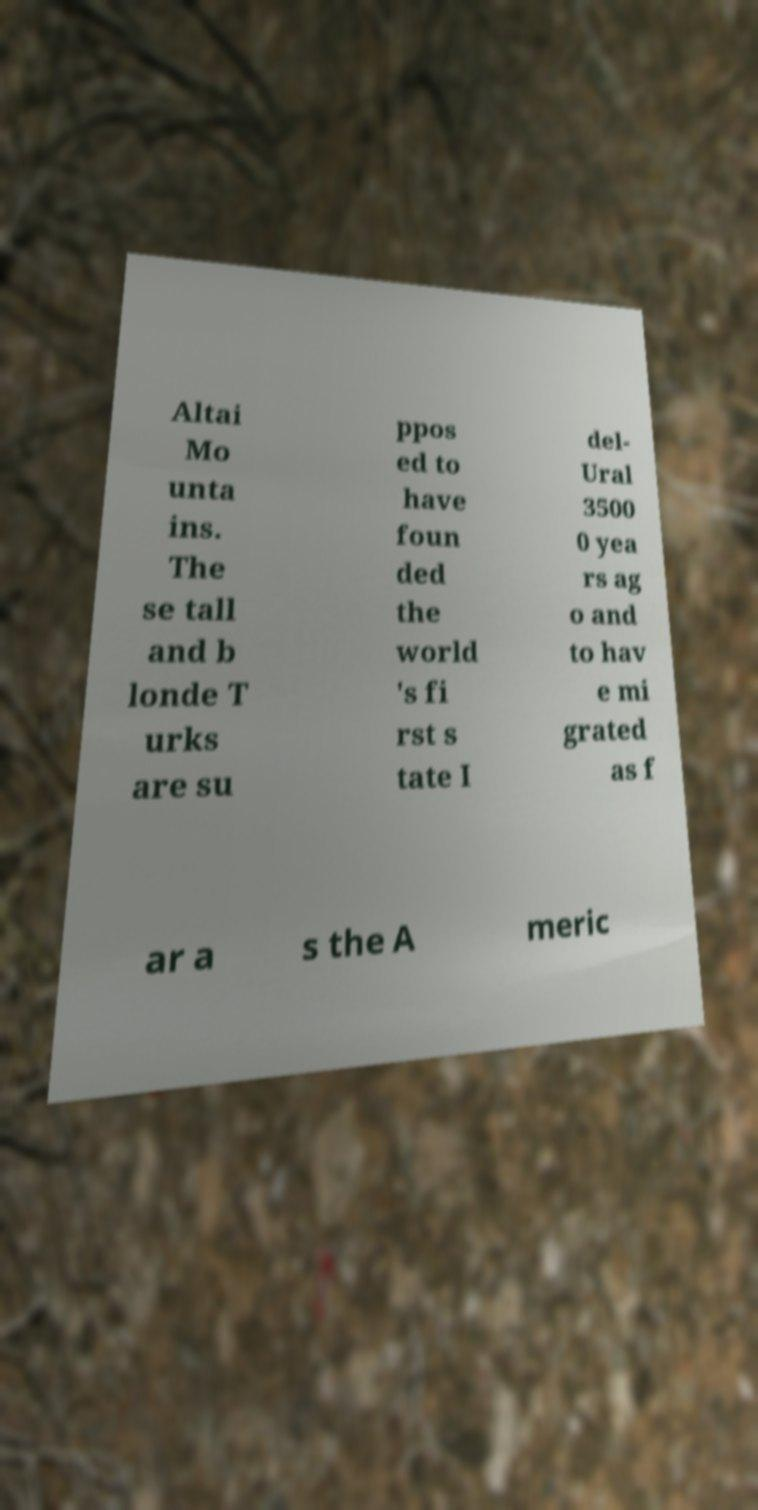Can you read and provide the text displayed in the image?This photo seems to have some interesting text. Can you extract and type it out for me? Altai Mo unta ins. The se tall and b londe T urks are su ppos ed to have foun ded the world 's fi rst s tate I del- Ural 3500 0 yea rs ag o and to hav e mi grated as f ar a s the A meric 